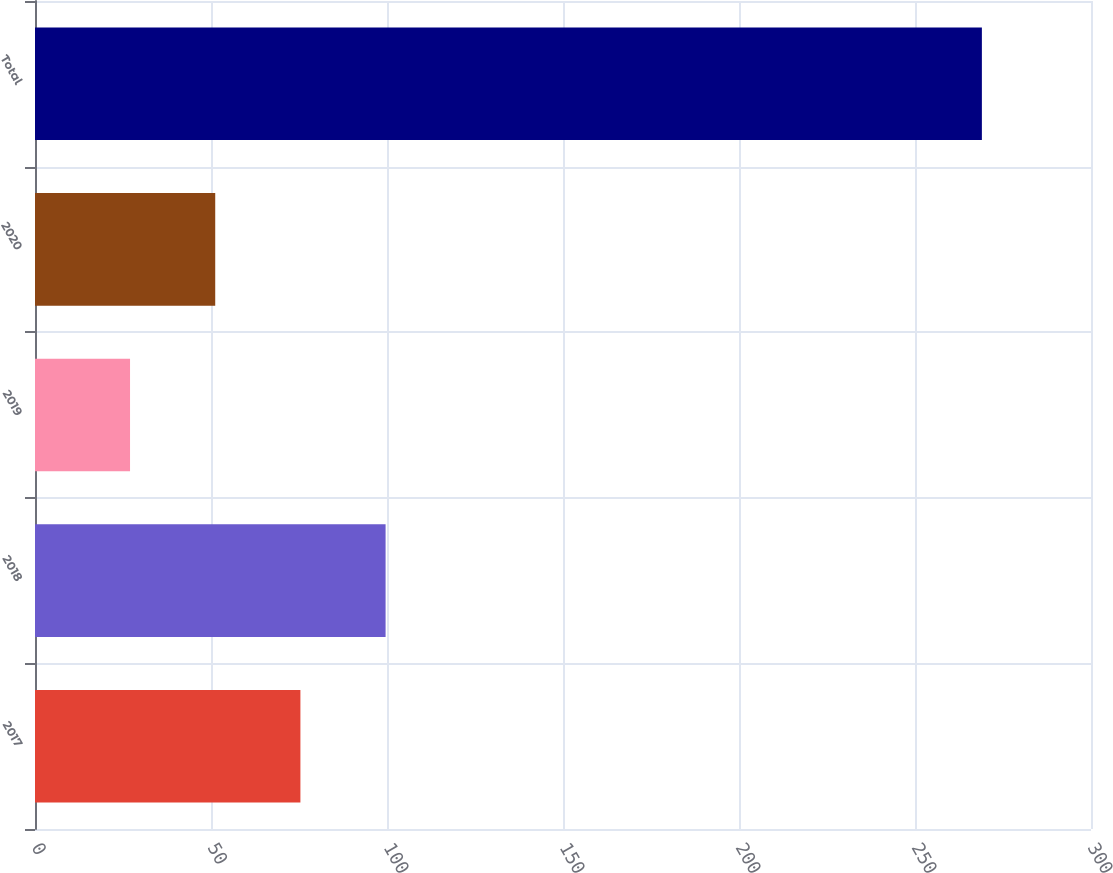Convert chart. <chart><loc_0><loc_0><loc_500><loc_500><bar_chart><fcel>2017<fcel>2018<fcel>2019<fcel>2020<fcel>Total<nl><fcel>75.4<fcel>99.6<fcel>27<fcel>51.2<fcel>269<nl></chart> 